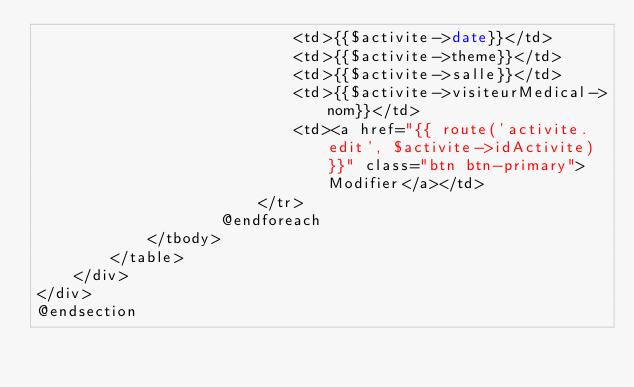<code> <loc_0><loc_0><loc_500><loc_500><_PHP_>                            <td>{{$activite->date}}</td>
                            <td>{{$activite->theme}}</td>
                            <td>{{$activite->salle}}</td>
                            <td>{{$activite->visiteurMedical->nom}}</td>
                            <td><a href="{{ route('activite.edit', $activite->idActivite)}}" class="btn btn-primary">Modifier</a></td>
                        </tr>
                    @endforeach
            </tbody>
        </table>
    </div>
</div>
@endsection
</code> 